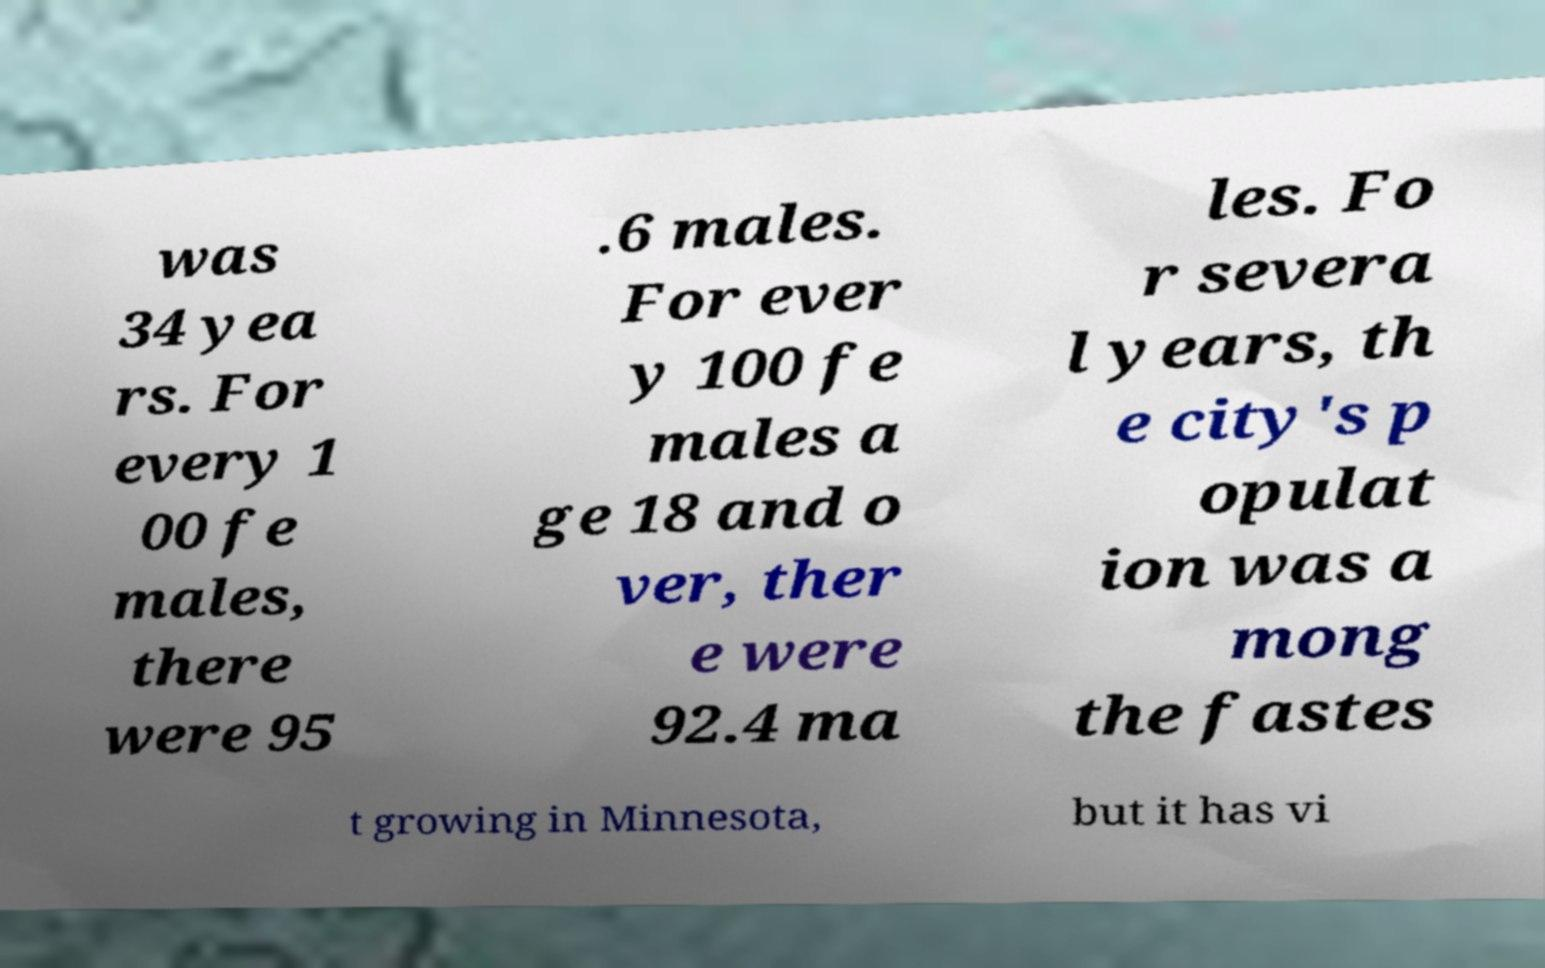Could you assist in decoding the text presented in this image and type it out clearly? was 34 yea rs. For every 1 00 fe males, there were 95 .6 males. For ever y 100 fe males a ge 18 and o ver, ther e were 92.4 ma les. Fo r severa l years, th e city's p opulat ion was a mong the fastes t growing in Minnesota, but it has vi 